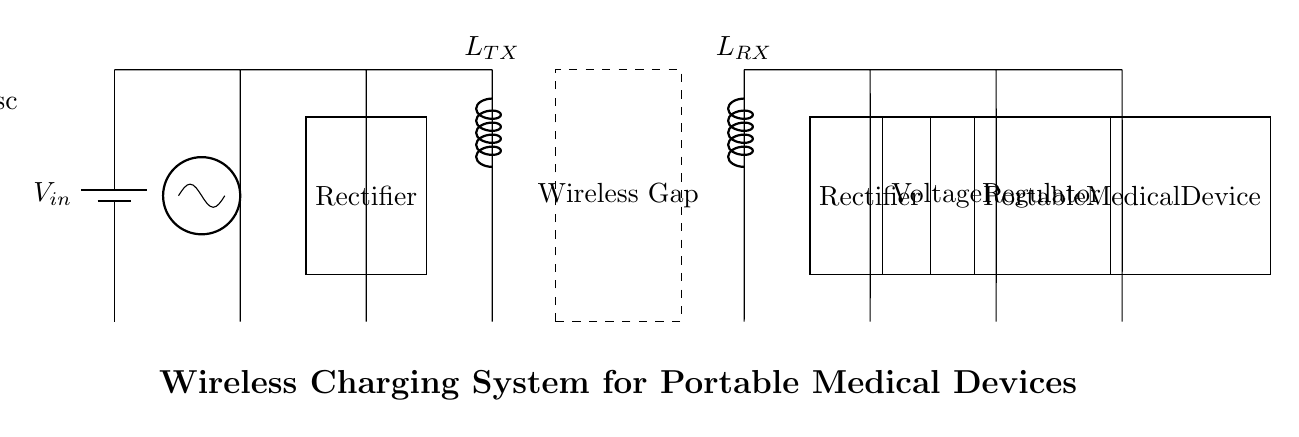What is the input source for this circuit? The input source is a battery, indicated by the battery symbol labeled as V_in at coordinate (0,0). This source provides the electrical energy necessary for the circuit to operate.
Answer: Battery What is the function of the oscillator in this circuit? The oscillator, labeled as "Osc," converts the direct current (from the battery) into an alternating current (AC) signal. This is necessary for wireless transmission of energy through the coils.
Answer: Alternating current generation What are the two types of coils present in this wireless charging system? There are two coils, identified as the transmitter coil (L_TX) and the receiver coil (L_RX). The transmitter coil is responsible for producing the magnetic field, while the receiver coil picks up the energy for the device.
Answer: Transmitter and receiver coils What components are used to make the output stable for the medical device? A rectifier and a voltage regulator are used. The rectifier converts AC from the receiver coil back into DC, and the voltage regulator ensures that the output voltage is within an acceptable range for the portable medical device.
Answer: Rectifier and voltage regulator How does the wireless gap impact the circuit? The wireless gap separates the transmitter and receiver coils, allowing for inductive coupling, where energy is transferred wirelessly through a magnetic field without the need for direct electrical connections.
Answer: Inductive coupling What type of device is being powered in this circuit? The load at the end of the circuit is labeled as a "Portable Medical Device," indicating that this system is designed to wirelessly charge medical equipment safely and conveniently.
Answer: Portable Medical Device 